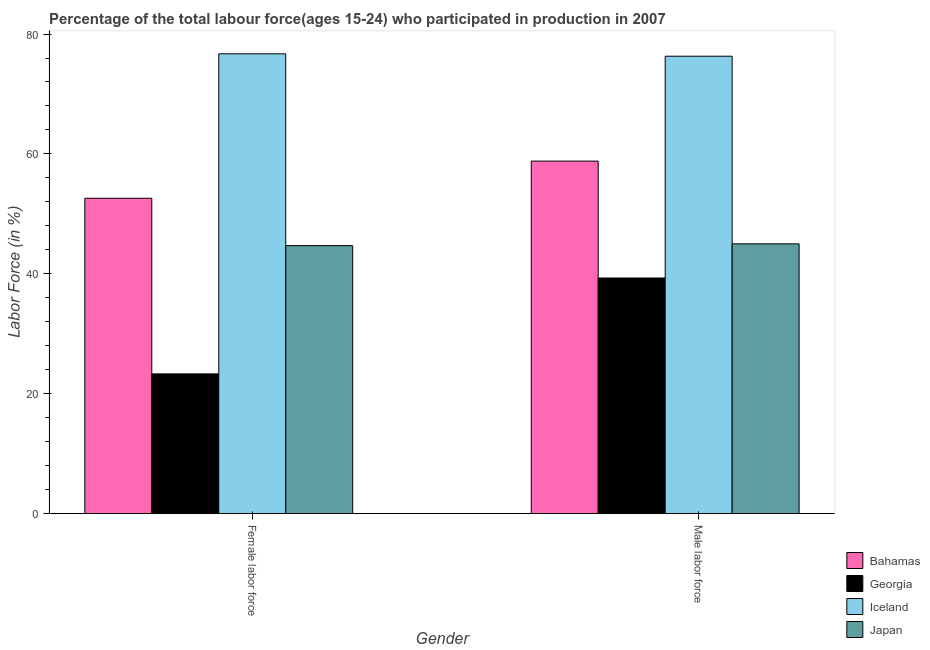How many groups of bars are there?
Your answer should be compact. 2. Are the number of bars on each tick of the X-axis equal?
Keep it short and to the point. Yes. How many bars are there on the 1st tick from the left?
Your answer should be compact. 4. What is the label of the 2nd group of bars from the left?
Ensure brevity in your answer.  Male labor force. What is the percentage of male labour force in Iceland?
Keep it short and to the point. 76.3. Across all countries, what is the maximum percentage of female labor force?
Your answer should be compact. 76.7. Across all countries, what is the minimum percentage of female labor force?
Give a very brief answer. 23.3. In which country was the percentage of female labor force minimum?
Your answer should be very brief. Georgia. What is the total percentage of female labor force in the graph?
Ensure brevity in your answer.  197.3. What is the difference between the percentage of male labour force in Georgia and that in Japan?
Keep it short and to the point. -5.7. What is the difference between the percentage of male labour force in Iceland and the percentage of female labor force in Georgia?
Your response must be concise. 53. What is the average percentage of male labour force per country?
Provide a succinct answer. 54.85. What is the difference between the percentage of male labour force and percentage of female labor force in Japan?
Provide a succinct answer. 0.3. In how many countries, is the percentage of female labor force greater than 32 %?
Offer a terse response. 3. What is the ratio of the percentage of female labor force in Georgia to that in Bahamas?
Give a very brief answer. 0.44. Is the percentage of male labour force in Bahamas less than that in Georgia?
Give a very brief answer. No. What does the 4th bar from the left in Male labor force represents?
Give a very brief answer. Japan. What does the 2nd bar from the right in Male labor force represents?
Offer a terse response. Iceland. Are all the bars in the graph horizontal?
Your response must be concise. No. Are the values on the major ticks of Y-axis written in scientific E-notation?
Your answer should be compact. No. Does the graph contain any zero values?
Provide a short and direct response. No. What is the title of the graph?
Offer a terse response. Percentage of the total labour force(ages 15-24) who participated in production in 2007. What is the label or title of the X-axis?
Provide a succinct answer. Gender. What is the Labor Force (in %) of Bahamas in Female labor force?
Provide a short and direct response. 52.6. What is the Labor Force (in %) in Georgia in Female labor force?
Your response must be concise. 23.3. What is the Labor Force (in %) of Iceland in Female labor force?
Your response must be concise. 76.7. What is the Labor Force (in %) of Japan in Female labor force?
Your response must be concise. 44.7. What is the Labor Force (in %) of Bahamas in Male labor force?
Your answer should be compact. 58.8. What is the Labor Force (in %) in Georgia in Male labor force?
Your response must be concise. 39.3. What is the Labor Force (in %) in Iceland in Male labor force?
Provide a short and direct response. 76.3. Across all Gender, what is the maximum Labor Force (in %) in Bahamas?
Your answer should be compact. 58.8. Across all Gender, what is the maximum Labor Force (in %) in Georgia?
Your response must be concise. 39.3. Across all Gender, what is the maximum Labor Force (in %) of Iceland?
Your response must be concise. 76.7. Across all Gender, what is the maximum Labor Force (in %) of Japan?
Your answer should be compact. 45. Across all Gender, what is the minimum Labor Force (in %) in Bahamas?
Ensure brevity in your answer.  52.6. Across all Gender, what is the minimum Labor Force (in %) in Georgia?
Provide a succinct answer. 23.3. Across all Gender, what is the minimum Labor Force (in %) in Iceland?
Give a very brief answer. 76.3. Across all Gender, what is the minimum Labor Force (in %) of Japan?
Keep it short and to the point. 44.7. What is the total Labor Force (in %) in Bahamas in the graph?
Your response must be concise. 111.4. What is the total Labor Force (in %) in Georgia in the graph?
Keep it short and to the point. 62.6. What is the total Labor Force (in %) of Iceland in the graph?
Offer a very short reply. 153. What is the total Labor Force (in %) of Japan in the graph?
Offer a terse response. 89.7. What is the difference between the Labor Force (in %) in Georgia in Female labor force and that in Male labor force?
Provide a short and direct response. -16. What is the difference between the Labor Force (in %) of Iceland in Female labor force and that in Male labor force?
Your response must be concise. 0.4. What is the difference between the Labor Force (in %) of Japan in Female labor force and that in Male labor force?
Provide a succinct answer. -0.3. What is the difference between the Labor Force (in %) of Bahamas in Female labor force and the Labor Force (in %) of Iceland in Male labor force?
Provide a short and direct response. -23.7. What is the difference between the Labor Force (in %) in Georgia in Female labor force and the Labor Force (in %) in Iceland in Male labor force?
Make the answer very short. -53. What is the difference between the Labor Force (in %) of Georgia in Female labor force and the Labor Force (in %) of Japan in Male labor force?
Offer a terse response. -21.7. What is the difference between the Labor Force (in %) in Iceland in Female labor force and the Labor Force (in %) in Japan in Male labor force?
Ensure brevity in your answer.  31.7. What is the average Labor Force (in %) of Bahamas per Gender?
Give a very brief answer. 55.7. What is the average Labor Force (in %) in Georgia per Gender?
Offer a very short reply. 31.3. What is the average Labor Force (in %) in Iceland per Gender?
Keep it short and to the point. 76.5. What is the average Labor Force (in %) of Japan per Gender?
Ensure brevity in your answer.  44.85. What is the difference between the Labor Force (in %) of Bahamas and Labor Force (in %) of Georgia in Female labor force?
Provide a short and direct response. 29.3. What is the difference between the Labor Force (in %) in Bahamas and Labor Force (in %) in Iceland in Female labor force?
Provide a succinct answer. -24.1. What is the difference between the Labor Force (in %) in Bahamas and Labor Force (in %) in Japan in Female labor force?
Make the answer very short. 7.9. What is the difference between the Labor Force (in %) of Georgia and Labor Force (in %) of Iceland in Female labor force?
Offer a very short reply. -53.4. What is the difference between the Labor Force (in %) of Georgia and Labor Force (in %) of Japan in Female labor force?
Offer a very short reply. -21.4. What is the difference between the Labor Force (in %) in Bahamas and Labor Force (in %) in Iceland in Male labor force?
Your answer should be very brief. -17.5. What is the difference between the Labor Force (in %) of Bahamas and Labor Force (in %) of Japan in Male labor force?
Offer a very short reply. 13.8. What is the difference between the Labor Force (in %) in Georgia and Labor Force (in %) in Iceland in Male labor force?
Make the answer very short. -37. What is the difference between the Labor Force (in %) of Iceland and Labor Force (in %) of Japan in Male labor force?
Make the answer very short. 31.3. What is the ratio of the Labor Force (in %) of Bahamas in Female labor force to that in Male labor force?
Your answer should be compact. 0.89. What is the ratio of the Labor Force (in %) in Georgia in Female labor force to that in Male labor force?
Ensure brevity in your answer.  0.59. What is the ratio of the Labor Force (in %) in Iceland in Female labor force to that in Male labor force?
Make the answer very short. 1.01. What is the ratio of the Labor Force (in %) in Japan in Female labor force to that in Male labor force?
Your answer should be very brief. 0.99. What is the difference between the highest and the lowest Labor Force (in %) of Bahamas?
Ensure brevity in your answer.  6.2. What is the difference between the highest and the lowest Labor Force (in %) of Georgia?
Your answer should be very brief. 16. What is the difference between the highest and the lowest Labor Force (in %) of Japan?
Keep it short and to the point. 0.3. 